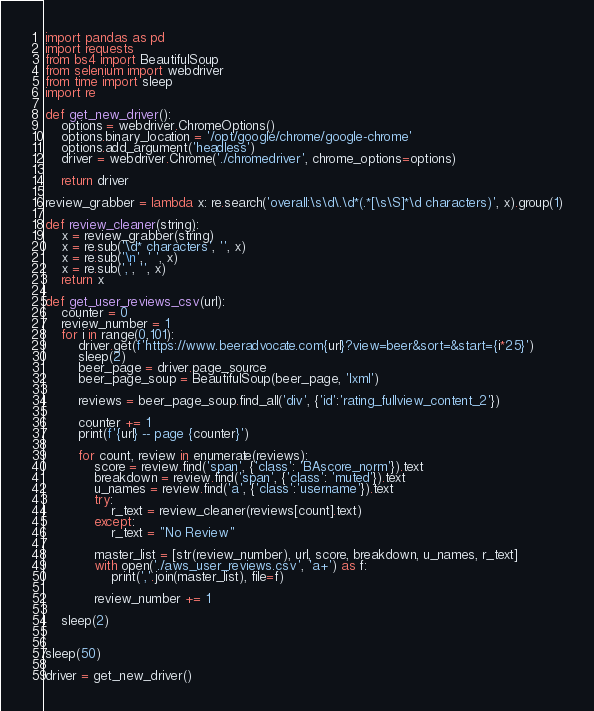<code> <loc_0><loc_0><loc_500><loc_500><_Python_>import pandas as pd
import requests
from bs4 import BeautifulSoup
from selenium import webdriver
from time import sleep
import re

def get_new_driver():
    options = webdriver.ChromeOptions()
    options.binary_location = '/opt/google/chrome/google-chrome'
    options.add_argument('headless')
    driver = webdriver.Chrome('./chromedriver', chrome_options=options)

    return driver

review_grabber = lambda x: re.search('overall:\s\d\.\d*(.*[\s\S]*\d characters)', x).group(1)

def review_cleaner(string):
    x = review_grabber(string)
    x = re.sub('\d* characters', '', x)
    x = re.sub('\n', ' ', x)
    x = re.sub(',', '', x)
    return x

def get_user_reviews_csv(url):
    counter = 0
    review_number = 1
    for i in range(0,101):
        driver.get(f'https://www.beeradvocate.com{url}?view=beer&sort=&start={i*25}')
        sleep(2)
        beer_page = driver.page_source
        beer_page_soup = BeautifulSoup(beer_page, 'lxml')
        
        reviews = beer_page_soup.find_all('div', {'id':'rating_fullview_content_2'})
        
        counter += 1
        print(f'{url} -- page {counter}')
        
        for count, review in enumerate(reviews):
            score = review.find('span', {'class': 'BAscore_norm'}).text
            breakdown = review.find('span', {'class': 'muted'}).text
            u_names = review.find('a', {'class':'username'}).text
            try:
                r_text = review_cleaner(reviews[count].text)
            except:
                r_text = "No Review"
                
            master_list = [str(review_number), url, score, breakdown, u_names, r_text]
            with open('./aws_user_reviews.csv', 'a+') as f:
                print(','.join(master_list), file=f)
            
            review_number += 1
    
    sleep(2)


sleep(50)

driver = get_new_driver()</code> 